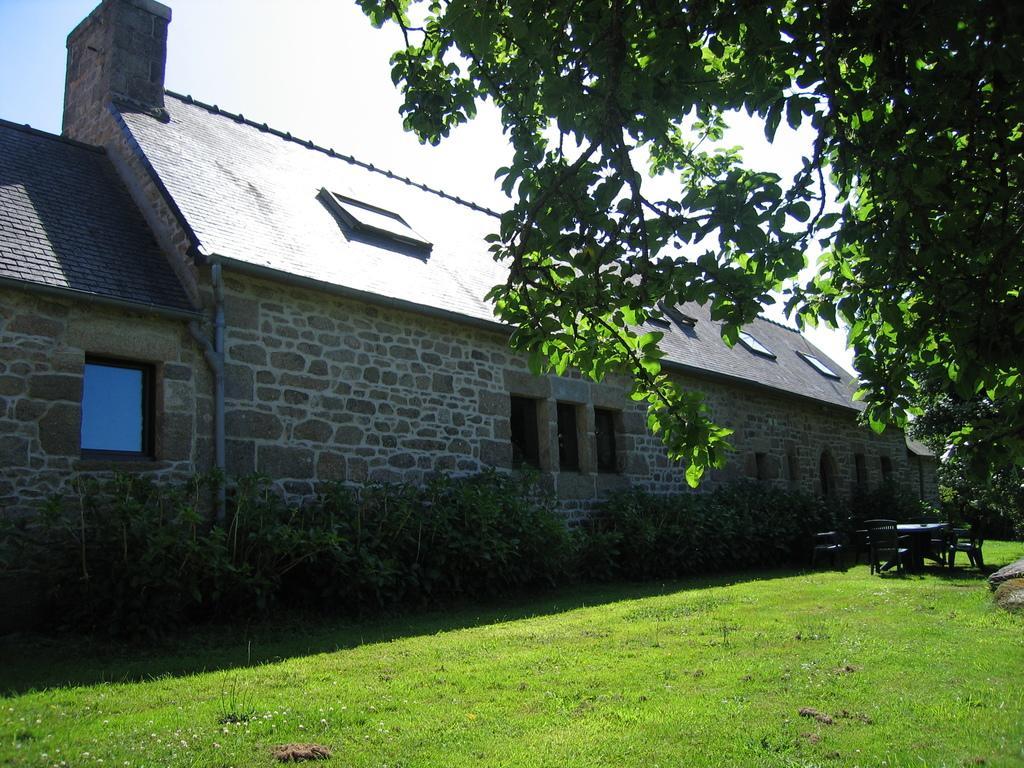Can you describe this image briefly? In this image we can see a house with glass windows. On the right side of the image, we can see tree, table and chairs. At the bottom of the image, there is a grassy land. In front of the house, we can see plants. At the top of the image, there is the sky with clouds. 